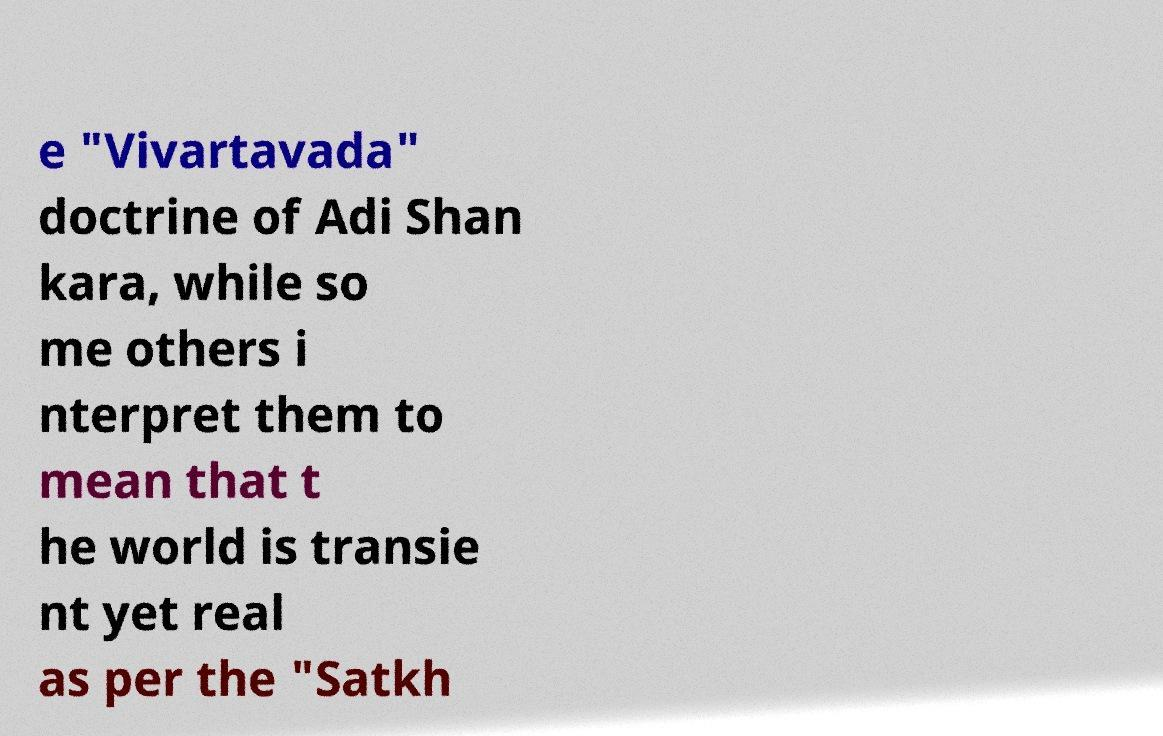For documentation purposes, I need the text within this image transcribed. Could you provide that? e "Vivartavada" doctrine of Adi Shan kara, while so me others i nterpret them to mean that t he world is transie nt yet real as per the "Satkh 